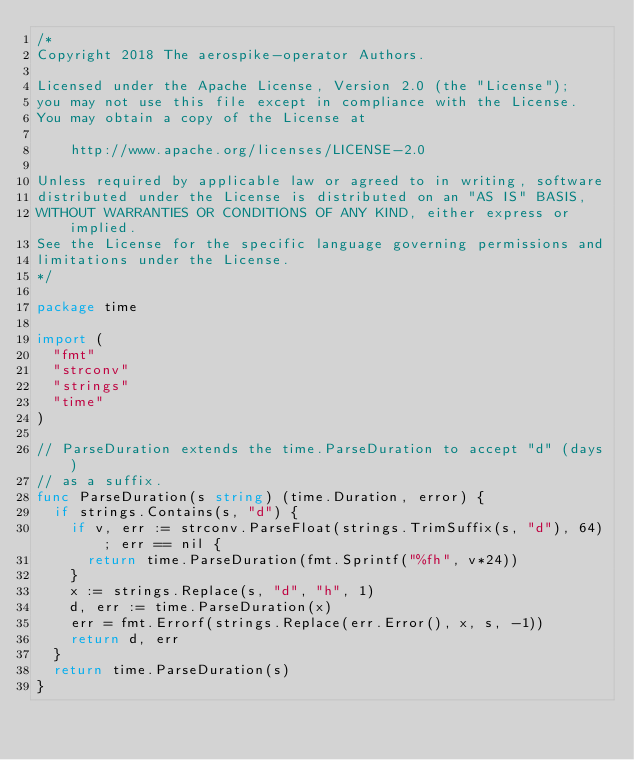Convert code to text. <code><loc_0><loc_0><loc_500><loc_500><_Go_>/*
Copyright 2018 The aerospike-operator Authors.

Licensed under the Apache License, Version 2.0 (the "License");
you may not use this file except in compliance with the License.
You may obtain a copy of the License at

    http://www.apache.org/licenses/LICENSE-2.0

Unless required by applicable law or agreed to in writing, software
distributed under the License is distributed on an "AS IS" BASIS,
WITHOUT WARRANTIES OR CONDITIONS OF ANY KIND, either express or implied.
See the License for the specific language governing permissions and
limitations under the License.
*/

package time

import (
	"fmt"
	"strconv"
	"strings"
	"time"
)

// ParseDuration extends the time.ParseDuration to accept "d" (days)
// as a suffix.
func ParseDuration(s string) (time.Duration, error) {
	if strings.Contains(s, "d") {
		if v, err := strconv.ParseFloat(strings.TrimSuffix(s, "d"), 64); err == nil {
			return time.ParseDuration(fmt.Sprintf("%fh", v*24))
		}
		x := strings.Replace(s, "d", "h", 1)
		d, err := time.ParseDuration(x)
		err = fmt.Errorf(strings.Replace(err.Error(), x, s, -1))
		return d, err
	}
	return time.ParseDuration(s)
}
</code> 